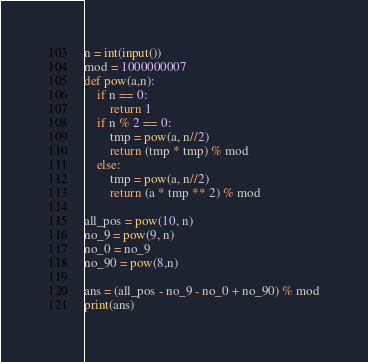<code> <loc_0><loc_0><loc_500><loc_500><_Python_>n = int(input())
mod = 1000000007
def pow(a,n):
    if n == 0:
        return 1
    if n % 2 == 0:
        tmp = pow(a, n//2)
        return (tmp * tmp) % mod
    else:
        tmp = pow(a, n//2)
        return (a * tmp ** 2) % mod

all_pos = pow(10, n)
no_9 = pow(9, n)
no_0 = no_9
no_90 = pow(8,n)

ans = (all_pos - no_9 - no_0 + no_90) % mod
print(ans)
</code> 